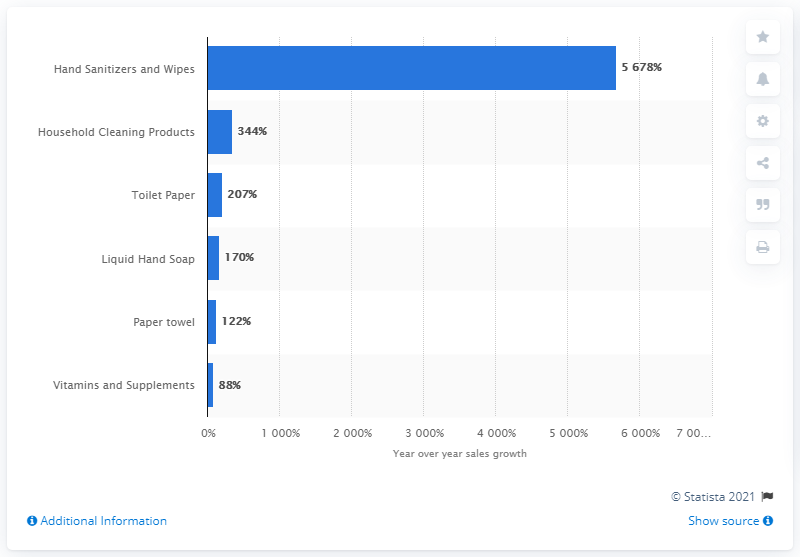Mention a couple of crucial points in this snapshot. Online sales of toilet paper increased significantly in March 2020, as evidenced by the fact that 207 was the highest monthly amount recorded during that time period. Online sales of hand sanitizer and wipes grew significantly in March, 2020. 